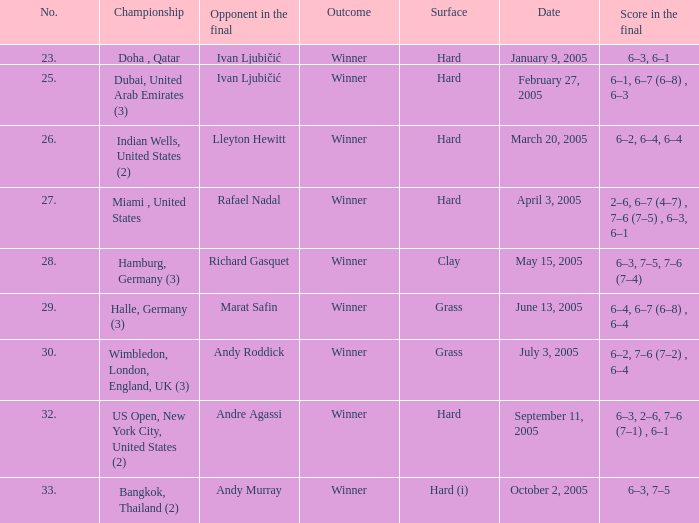In the championship Miami , United States, what is the score in the final? 2–6, 6–7 (4–7) , 7–6 (7–5) , 6–3, 6–1. 